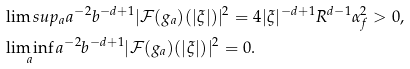<formula> <loc_0><loc_0><loc_500><loc_500>& \lim s u p _ { a } a ^ { - 2 } b ^ { - d + 1 } | \mathcal { F } ( g _ { a } ) ( | \xi | ) | ^ { 2 } = 4 | \xi | ^ { - d + 1 } R ^ { d - 1 } \alpha _ { f } ^ { 2 } > 0 , \\ & \liminf _ { a } a ^ { - 2 } b ^ { - d + 1 } | \mathcal { F } ( g _ { a } ) ( | \xi | ) | ^ { 2 } = 0 .</formula> 